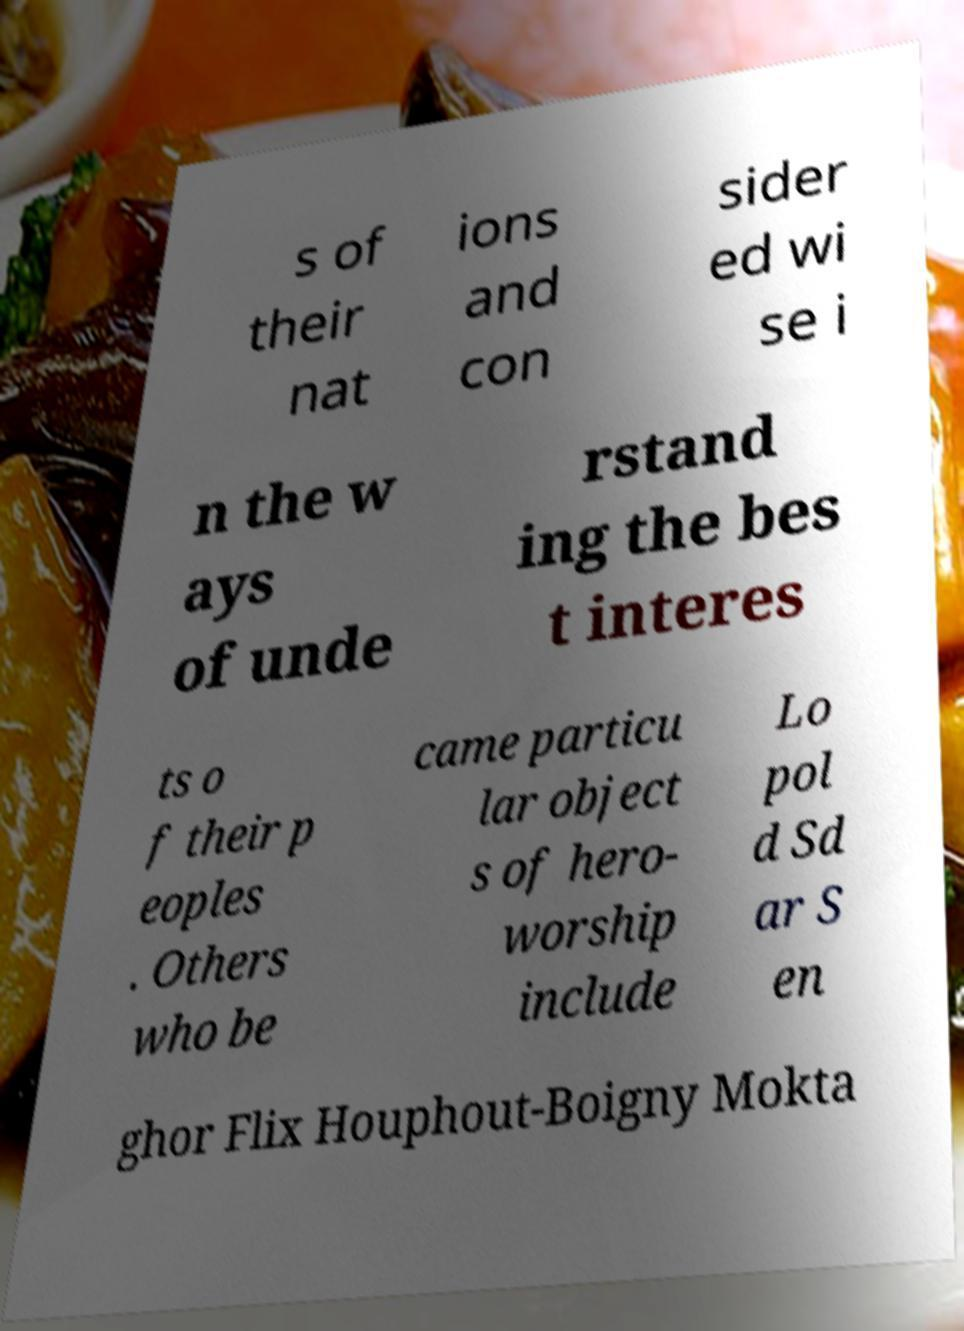I need the written content from this picture converted into text. Can you do that? s of their nat ions and con sider ed wi se i n the w ays of unde rstand ing the bes t interes ts o f their p eoples . Others who be came particu lar object s of hero- worship include Lo pol d Sd ar S en ghor Flix Houphout-Boigny Mokta 